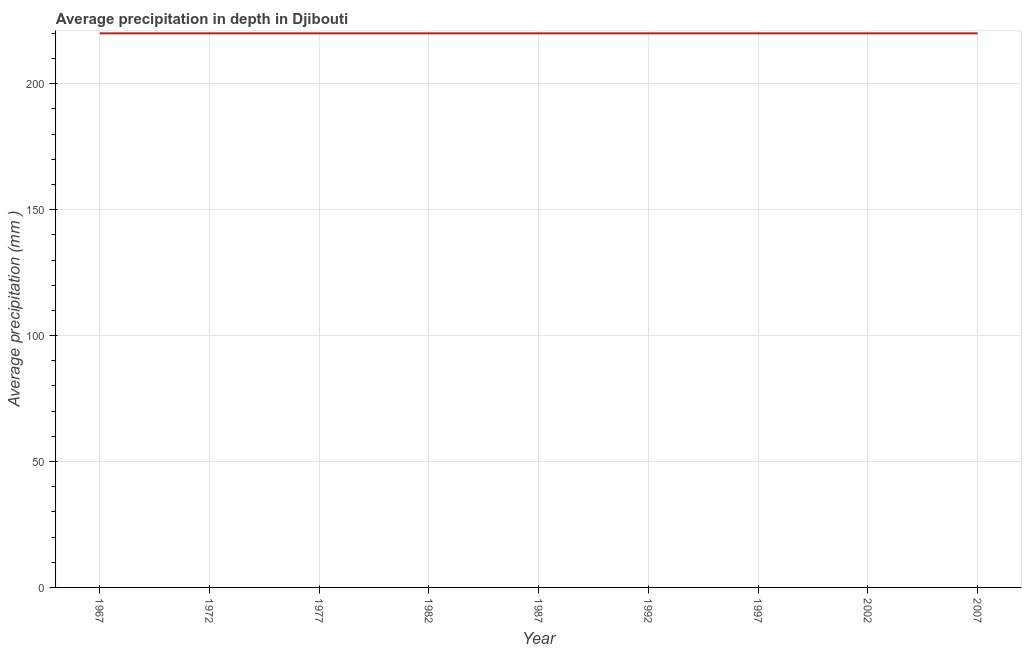What is the average precipitation in depth in 1977?
Offer a terse response. 220. Across all years, what is the maximum average precipitation in depth?
Provide a short and direct response. 220. Across all years, what is the minimum average precipitation in depth?
Your answer should be very brief. 220. In which year was the average precipitation in depth maximum?
Your answer should be very brief. 1967. In which year was the average precipitation in depth minimum?
Your answer should be compact. 1967. What is the difference between the average precipitation in depth in 1987 and 1997?
Offer a very short reply. 0. What is the average average precipitation in depth per year?
Your response must be concise. 220. What is the median average precipitation in depth?
Your answer should be very brief. 220. In how many years, is the average precipitation in depth greater than 120 mm?
Your answer should be very brief. 9. Do a majority of the years between 1987 and 2007 (inclusive) have average precipitation in depth greater than 100 mm?
Provide a short and direct response. Yes. What is the ratio of the average precipitation in depth in 1987 to that in 2007?
Provide a succinct answer. 1. Is the average precipitation in depth in 1972 less than that in 2007?
Your response must be concise. No. Is the difference between the average precipitation in depth in 1972 and 2007 greater than the difference between any two years?
Provide a succinct answer. Yes. What is the difference between the highest and the second highest average precipitation in depth?
Offer a very short reply. 0. What is the difference between the highest and the lowest average precipitation in depth?
Your response must be concise. 0. What is the difference between two consecutive major ticks on the Y-axis?
Your answer should be very brief. 50. What is the title of the graph?
Offer a terse response. Average precipitation in depth in Djibouti. What is the label or title of the Y-axis?
Provide a short and direct response. Average precipitation (mm ). What is the Average precipitation (mm ) of 1967?
Provide a succinct answer. 220. What is the Average precipitation (mm ) in 1972?
Offer a terse response. 220. What is the Average precipitation (mm ) of 1977?
Offer a terse response. 220. What is the Average precipitation (mm ) of 1982?
Offer a terse response. 220. What is the Average precipitation (mm ) in 1987?
Offer a very short reply. 220. What is the Average precipitation (mm ) of 1992?
Give a very brief answer. 220. What is the Average precipitation (mm ) in 1997?
Offer a terse response. 220. What is the Average precipitation (mm ) of 2002?
Give a very brief answer. 220. What is the Average precipitation (mm ) of 2007?
Your response must be concise. 220. What is the difference between the Average precipitation (mm ) in 1967 and 2002?
Keep it short and to the point. 0. What is the difference between the Average precipitation (mm ) in 1967 and 2007?
Your answer should be very brief. 0. What is the difference between the Average precipitation (mm ) in 1972 and 1977?
Provide a short and direct response. 0. What is the difference between the Average precipitation (mm ) in 1972 and 1982?
Your answer should be very brief. 0. What is the difference between the Average precipitation (mm ) in 1972 and 1992?
Ensure brevity in your answer.  0. What is the difference between the Average precipitation (mm ) in 1972 and 2007?
Make the answer very short. 0. What is the difference between the Average precipitation (mm ) in 1977 and 1982?
Give a very brief answer. 0. What is the difference between the Average precipitation (mm ) in 1977 and 1987?
Provide a short and direct response. 0. What is the difference between the Average precipitation (mm ) in 1977 and 1997?
Provide a succinct answer. 0. What is the difference between the Average precipitation (mm ) in 1977 and 2002?
Your answer should be compact. 0. What is the difference between the Average precipitation (mm ) in 1982 and 1987?
Make the answer very short. 0. What is the difference between the Average precipitation (mm ) in 1982 and 2002?
Keep it short and to the point. 0. What is the difference between the Average precipitation (mm ) in 1982 and 2007?
Keep it short and to the point. 0. What is the difference between the Average precipitation (mm ) in 1987 and 1997?
Offer a very short reply. 0. What is the difference between the Average precipitation (mm ) in 1987 and 2002?
Ensure brevity in your answer.  0. What is the difference between the Average precipitation (mm ) in 1987 and 2007?
Provide a succinct answer. 0. What is the difference between the Average precipitation (mm ) in 1997 and 2002?
Make the answer very short. 0. What is the difference between the Average precipitation (mm ) in 2002 and 2007?
Keep it short and to the point. 0. What is the ratio of the Average precipitation (mm ) in 1967 to that in 1972?
Give a very brief answer. 1. What is the ratio of the Average precipitation (mm ) in 1967 to that in 1982?
Offer a terse response. 1. What is the ratio of the Average precipitation (mm ) in 1967 to that in 1987?
Give a very brief answer. 1. What is the ratio of the Average precipitation (mm ) in 1967 to that in 2002?
Your answer should be compact. 1. What is the ratio of the Average precipitation (mm ) in 1967 to that in 2007?
Keep it short and to the point. 1. What is the ratio of the Average precipitation (mm ) in 1972 to that in 1977?
Provide a succinct answer. 1. What is the ratio of the Average precipitation (mm ) in 1972 to that in 1982?
Provide a short and direct response. 1. What is the ratio of the Average precipitation (mm ) in 1972 to that in 2002?
Ensure brevity in your answer.  1. What is the ratio of the Average precipitation (mm ) in 1972 to that in 2007?
Keep it short and to the point. 1. What is the ratio of the Average precipitation (mm ) in 1977 to that in 1982?
Ensure brevity in your answer.  1. What is the ratio of the Average precipitation (mm ) in 1977 to that in 2007?
Offer a terse response. 1. What is the ratio of the Average precipitation (mm ) in 1982 to that in 1992?
Provide a short and direct response. 1. What is the ratio of the Average precipitation (mm ) in 1982 to that in 1997?
Offer a very short reply. 1. What is the ratio of the Average precipitation (mm ) in 1982 to that in 2002?
Ensure brevity in your answer.  1. What is the ratio of the Average precipitation (mm ) in 1987 to that in 1992?
Your answer should be very brief. 1. What is the ratio of the Average precipitation (mm ) in 1987 to that in 2002?
Provide a short and direct response. 1. What is the ratio of the Average precipitation (mm ) in 1992 to that in 2002?
Your answer should be very brief. 1. What is the ratio of the Average precipitation (mm ) in 1992 to that in 2007?
Make the answer very short. 1. What is the ratio of the Average precipitation (mm ) in 1997 to that in 2002?
Offer a very short reply. 1. 